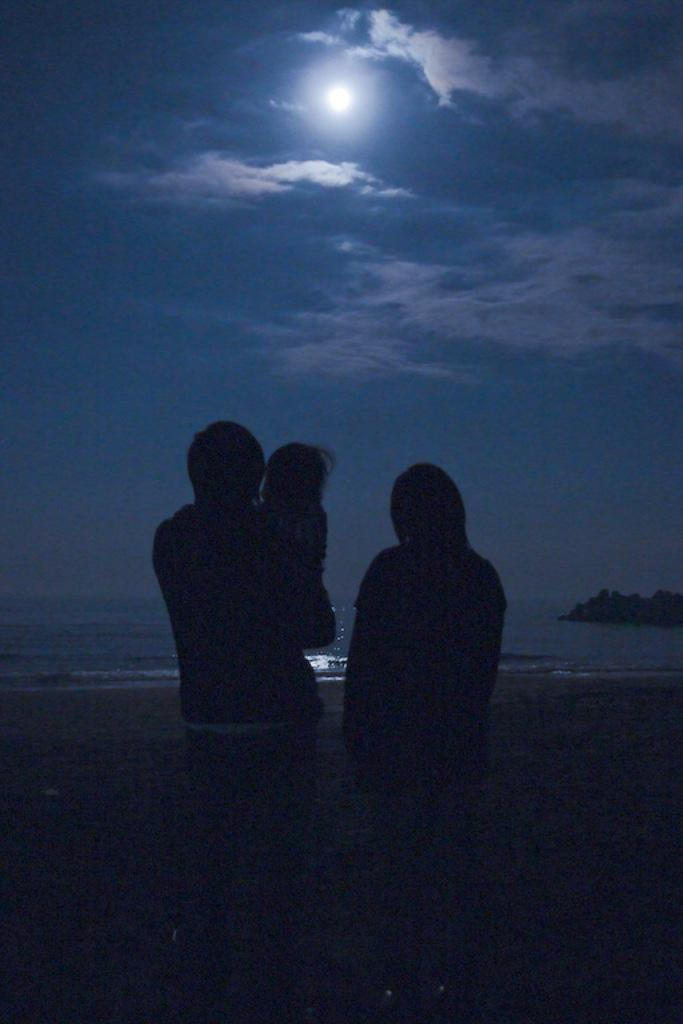How many people are present in the image? There are two people in the image, a woman and a man. What is the man doing in the image? The man is holding a baby in the image. What can be seen in the background of the picture? There is an ocean and the sky visible in the background of the picture. What celestial body is visible in the sky? There is a moon in the sky. What else can be seen in the sky? There are clouds in the sky. What type of copper object can be seen in the image? There is no copper object present in the image. Can you see an owl in the image? No, there is no owl present in the image. 